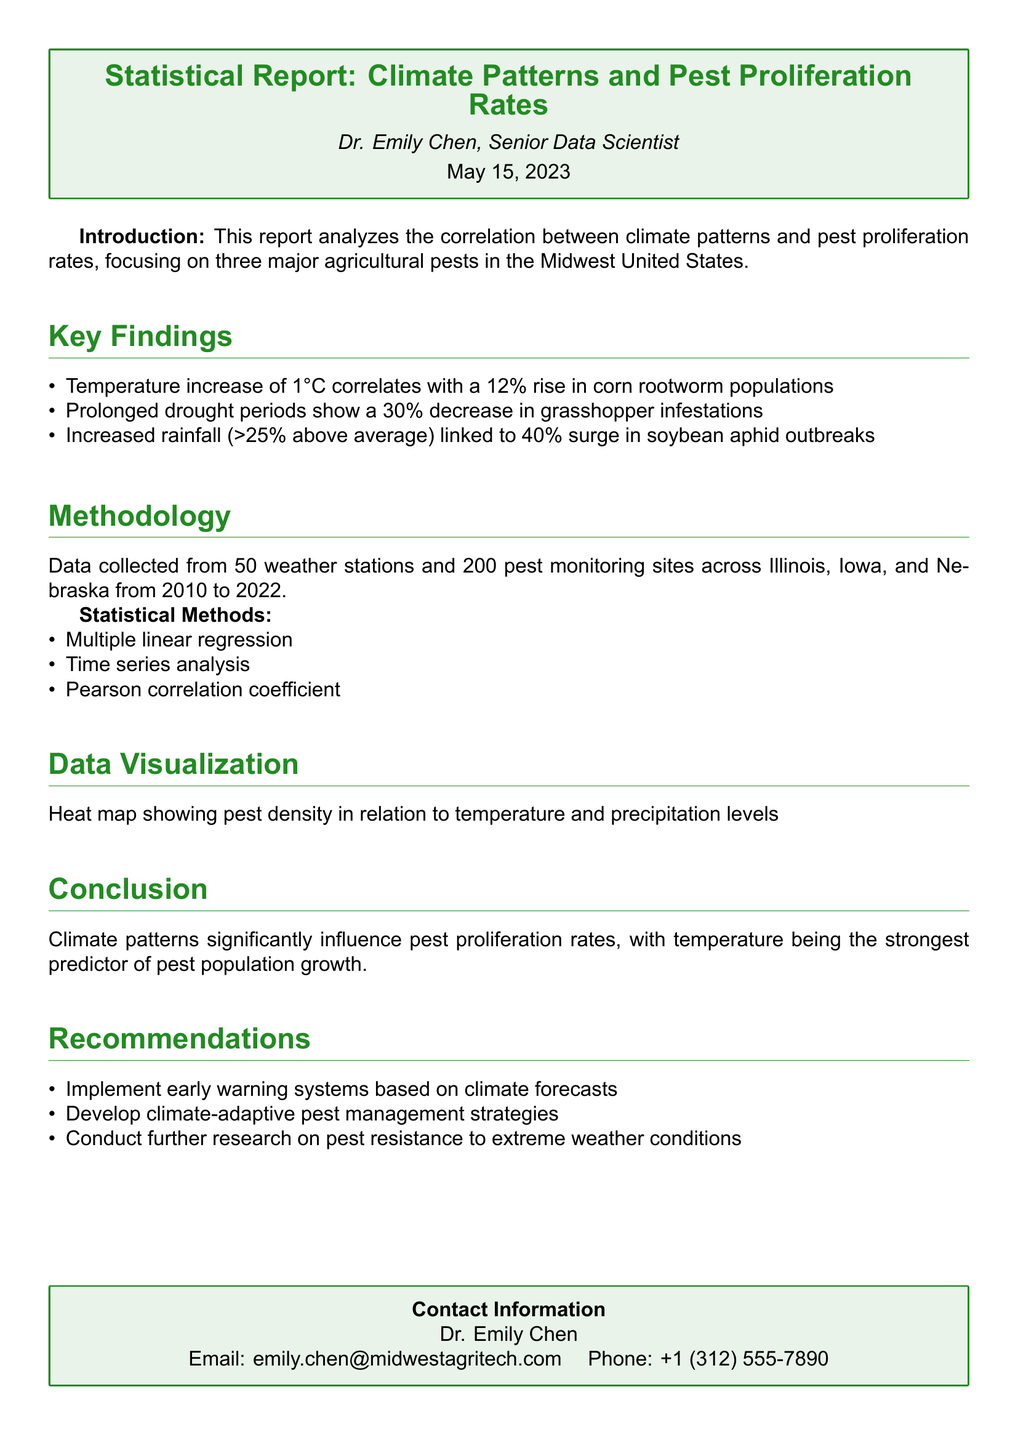What is the temperature increase correlated with corn rootworm populations? The report states that a temperature increase of 1°C correlates with a 12% rise in corn rootworm populations.
Answer: 12% What is the percentage decrease in grasshopper infestations during prolonged drought periods? According to the findings, prolonged drought periods show a 30% decrease in grasshopper infestations.
Answer: 30% How many weather stations were included in the data collection? The methodology section mentions that data was collected from 50 weather stations.
Answer: 50 Who is the author of the report? The document identifies Dr. Emily Chen as the author of the report.
Answer: Dr. Emily Chen What is the strongest predictor of pest population growth? The conclusion states that temperature is the strongest predictor of pest population growth.
Answer: Temperature What is the percentage surge in soybean aphid outbreaks linked to increased rainfall? The report indicates that increased rainfall greater than 25% above average is linked to a 40% surge in soybean aphid outbreaks.
Answer: 40% What type of statistical methods were employed in the analysis? The methodology section lists multiple linear regression, time series analysis, and Pearson correlation coefficient as the statistical methods used.
Answer: Multiple linear regression, time series analysis, Pearson correlation coefficient What is one recommendation made in the report for pest management? The recommendations suggest implementing early warning systems based on climate forecasts as a strategy for pest management.
Answer: Implement early warning systems 